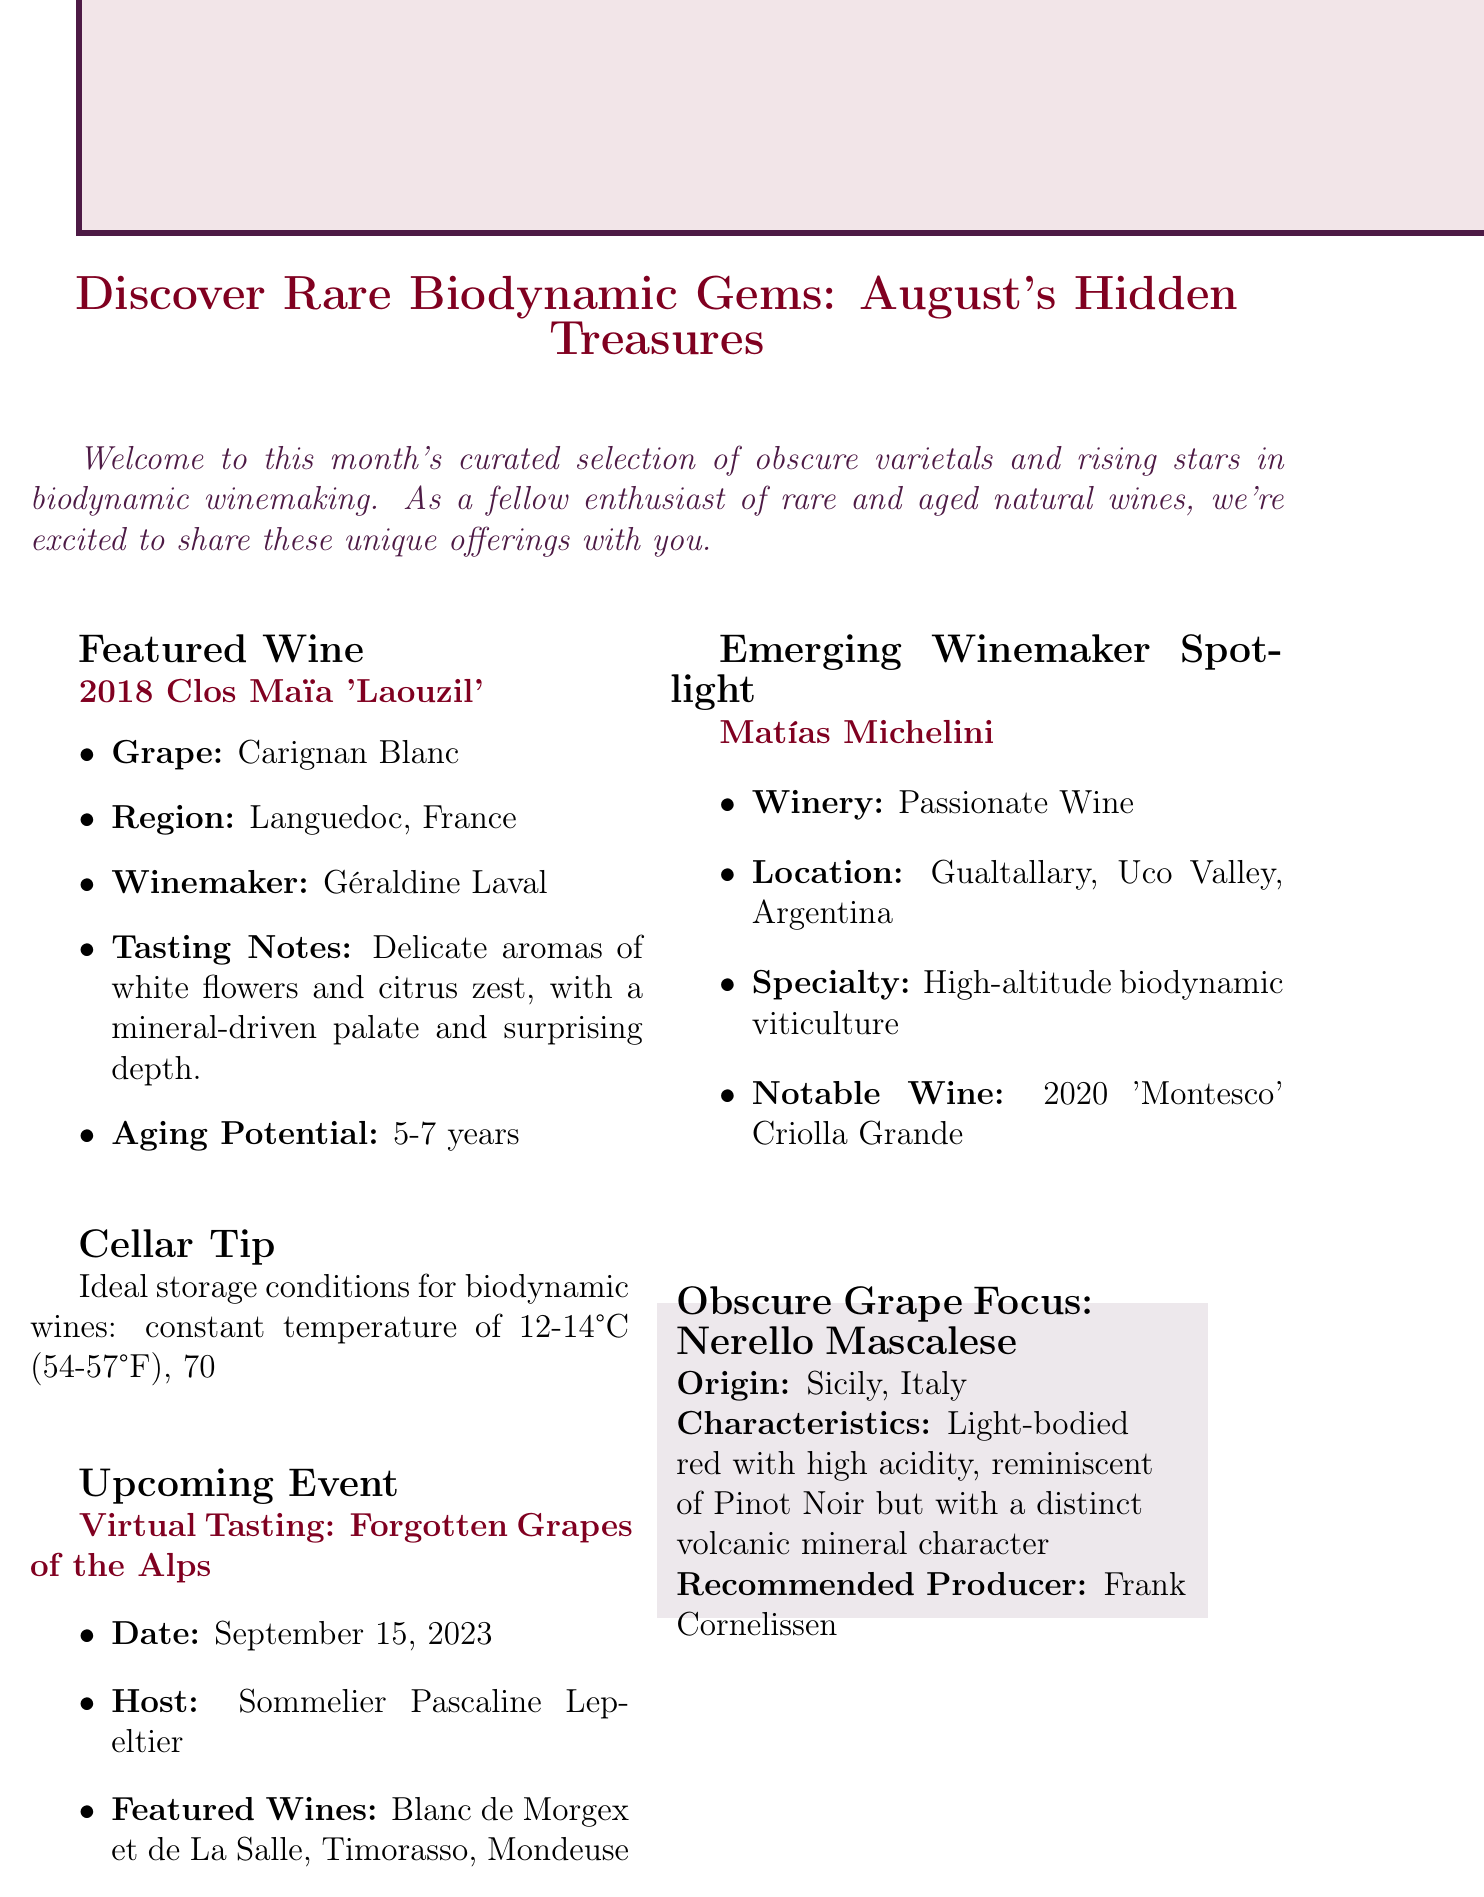What is the featured wine for August? The featured wine for August is specifically mentioned in the document as the 2018 Clos Maïa 'Laouzil'.
Answer: 2018 Clos Maïa 'Laouzil' Who is the winemaker of the featured wine? The winemaker's name is provided in the details of the featured wine section.
Answer: Géraldine Laval What grape variety is highlighted in the obscure grape focus section? The grape variety mentioned in that section is explicitly stated in the document.
Answer: Nerello Mascalese What is the aging potential of the featured wine? The aging potential is clearly noted under the featured wine section, providing a specific time frame.
Answer: 5-7 years Where is Matías Michelini's winery located? The location of Matías Michelini's winery is included in the emerging winemaker spotlight.
Answer: Gualtallary, Uco Valley, Argentina What event is scheduled for September 15, 2023? The upcoming event scheduled on this date is detailed in the document, including its title.
Answer: Virtual Tasting: Forgotten Grapes of the Alps What is the recommended producer for Nerello Mascalese? The recommended producer is specified in the obscure grape focus section.
Answer: Frank Cornelissen What are the ideal storage conditions for biodynamic wines? The cellar tip section outlines specific conditions for storing biodynamic wines.
Answer: constant temperature of 12-14°C (54-57°F), 70% humidity, and minimal light exposure 